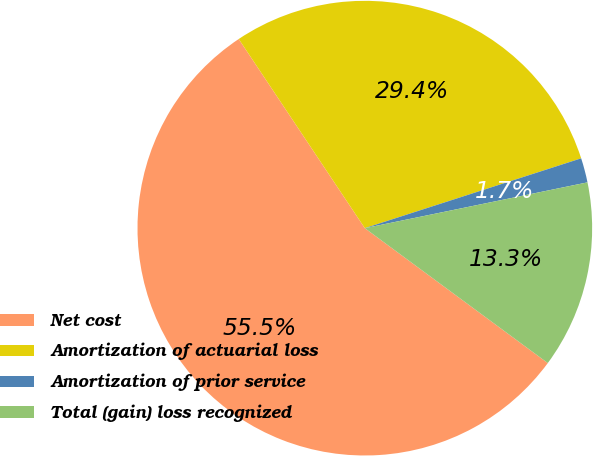Convert chart to OTSL. <chart><loc_0><loc_0><loc_500><loc_500><pie_chart><fcel>Net cost<fcel>Amortization of actuarial loss<fcel>Amortization of prior service<fcel>Total (gain) loss recognized<nl><fcel>55.53%<fcel>29.39%<fcel>1.74%<fcel>13.34%<nl></chart> 